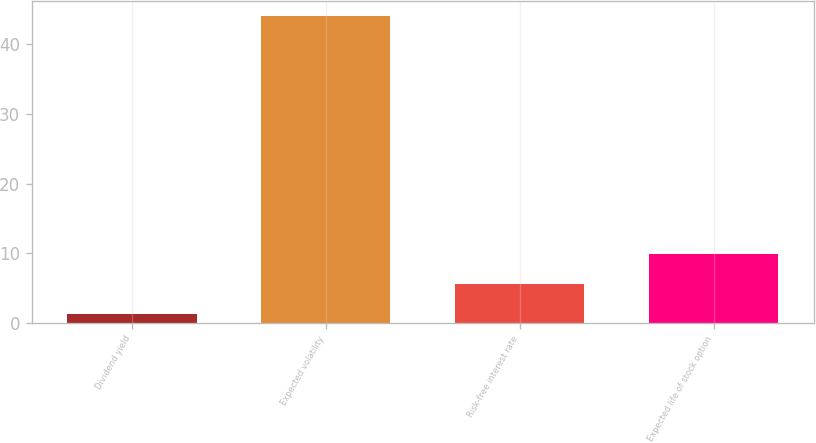Convert chart. <chart><loc_0><loc_0><loc_500><loc_500><bar_chart><fcel>Dividend yield<fcel>Expected volatility<fcel>Risk-free interest rate<fcel>Expected life of stock option<nl><fcel>1.3<fcel>44<fcel>5.57<fcel>9.84<nl></chart> 